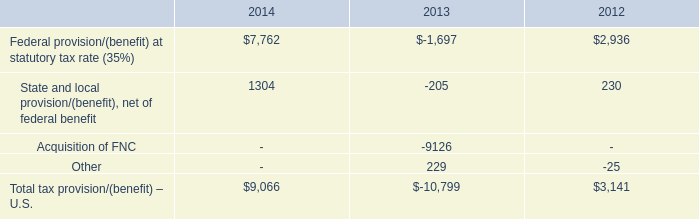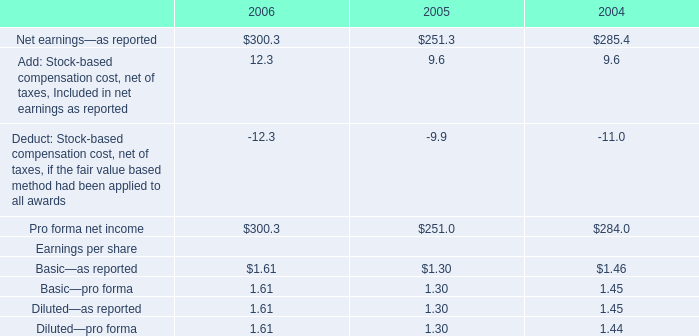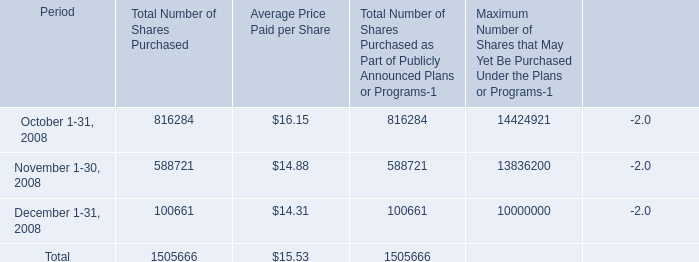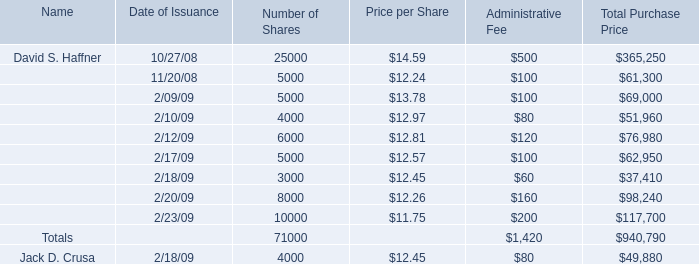what percentage of the total tax benefits came from the acquisition of fnc? 
Computations: (9126 / 10799)
Answer: 0.84508. 